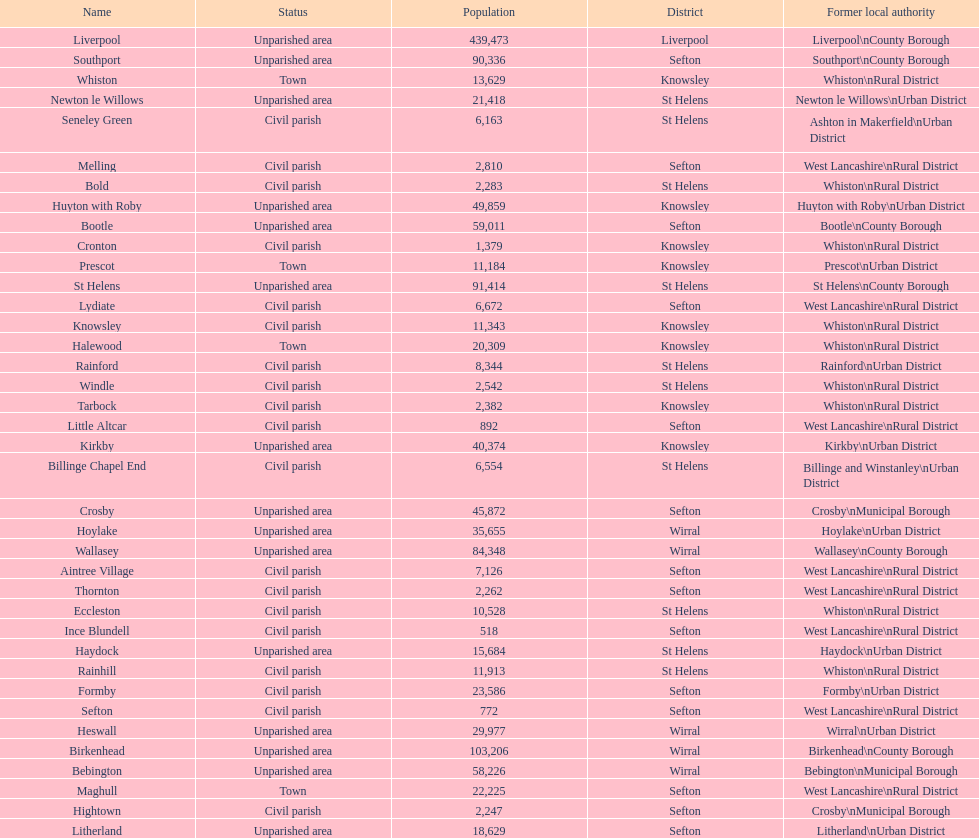How many civil parishes have population counts of at least 10,000? 4. 